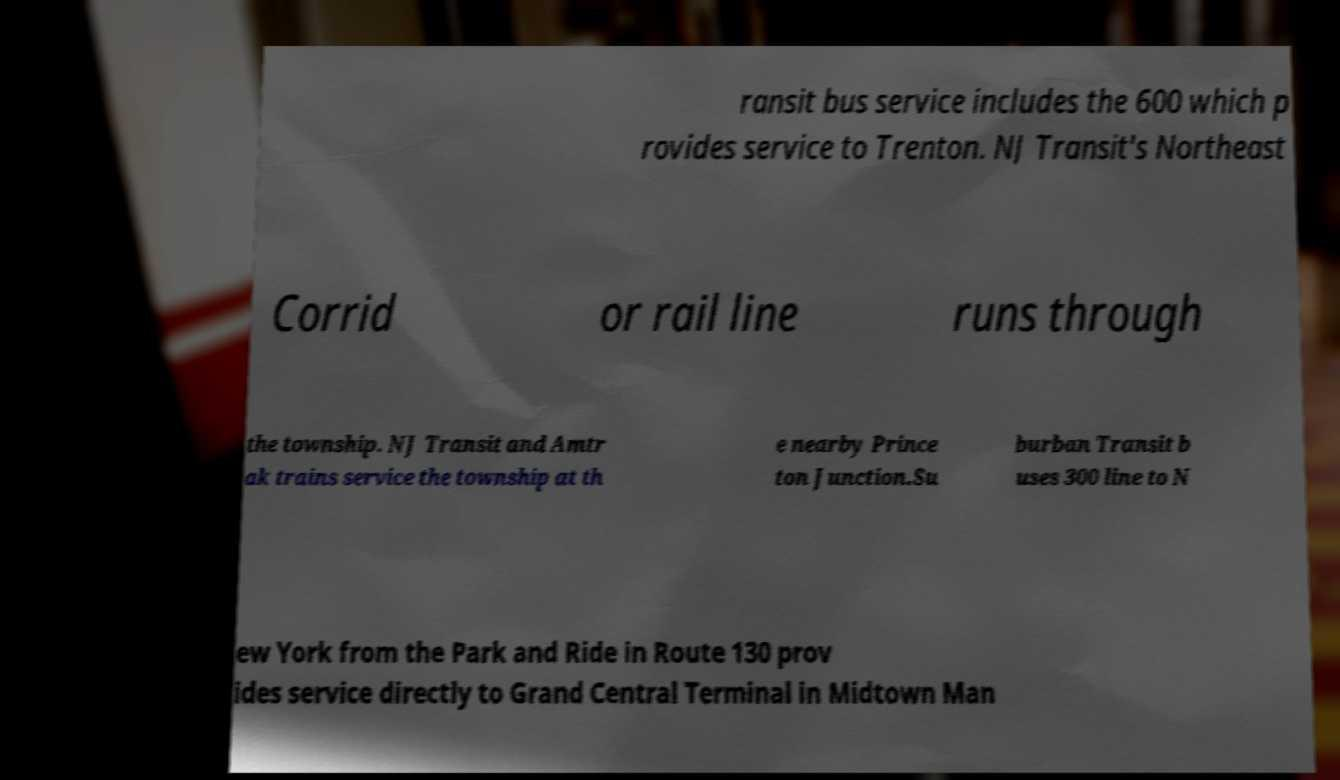What messages or text are displayed in this image? I need them in a readable, typed format. ransit bus service includes the 600 which p rovides service to Trenton. NJ Transit's Northeast Corrid or rail line runs through the township. NJ Transit and Amtr ak trains service the township at th e nearby Prince ton Junction.Su burban Transit b uses 300 line to N ew York from the Park and Ride in Route 130 prov ides service directly to Grand Central Terminal in Midtown Man 